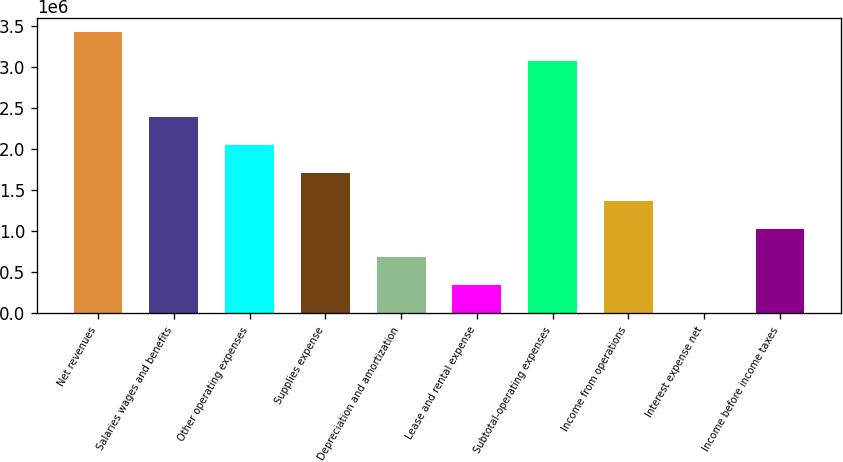<chart> <loc_0><loc_0><loc_500><loc_500><bar_chart><fcel>Net revenues<fcel>Salaries wages and benefits<fcel>Other operating expenses<fcel>Supplies expense<fcel>Depreciation and amortization<fcel>Lease and rental expense<fcel>Subtotal-operating expenses<fcel>Income from operations<fcel>Interest expense net<fcel>Income before income taxes<nl><fcel>3.42396e+06<fcel>2.39794e+06<fcel>2.05594e+06<fcel>1.71393e+06<fcel>687914<fcel>345908<fcel>3.07729e+06<fcel>1.37192e+06<fcel>3903<fcel>1.02992e+06<nl></chart> 